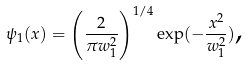<formula> <loc_0><loc_0><loc_500><loc_500>\psi _ { 1 } ( x ) = \left ( \frac { 2 } { \pi w _ { 1 } ^ { 2 } } \right ) ^ { 1 / 4 } \exp ( - \frac { x ^ { 2 } } { w _ { 1 } ^ { 2 } } ) \text {,}</formula> 